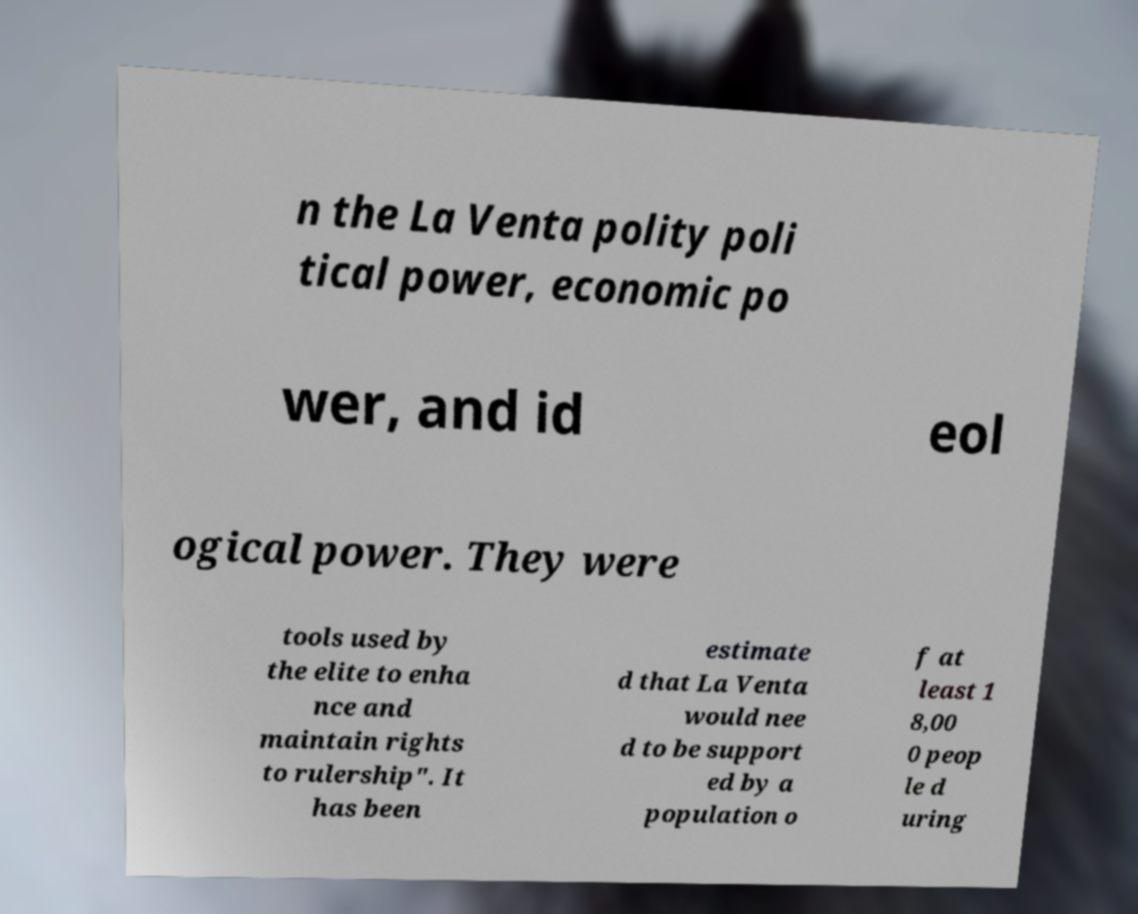Please read and relay the text visible in this image. What does it say? n the La Venta polity poli tical power, economic po wer, and id eol ogical power. They were tools used by the elite to enha nce and maintain rights to rulership". It has been estimate d that La Venta would nee d to be support ed by a population o f at least 1 8,00 0 peop le d uring 